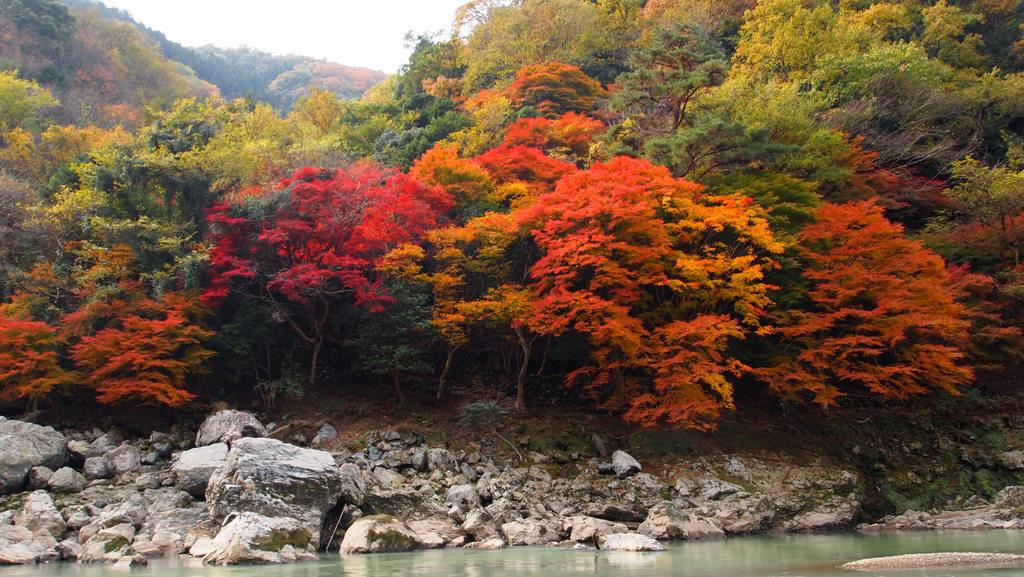What type of natural elements can be seen in the image? There are stones and water visible in the image. What can be seen in the background of the image? There are trees and the sky visible in the background of the image. What is the color of the trees in the image? The trees are green in color. What is the color of the sky in the image? The sky is white in color. Where is the jar located in the image? There is no jar present in the image. What type of bone can be seen in the image? There is no bone present in the image. 